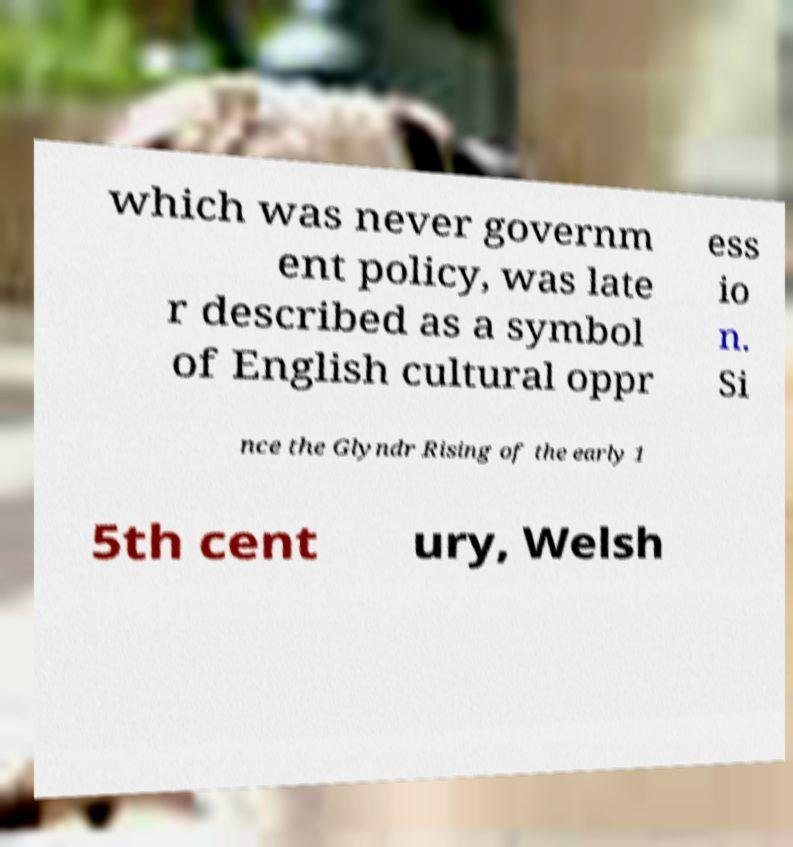I need the written content from this picture converted into text. Can you do that? which was never governm ent policy, was late r described as a symbol of English cultural oppr ess io n. Si nce the Glyndr Rising of the early 1 5th cent ury, Welsh 